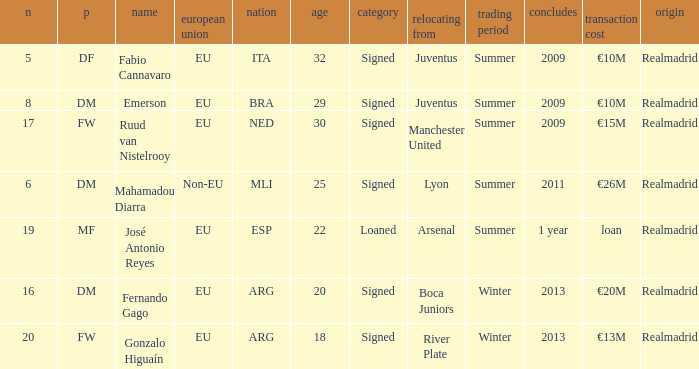How many numbers are ending in 1 year? 1.0. 